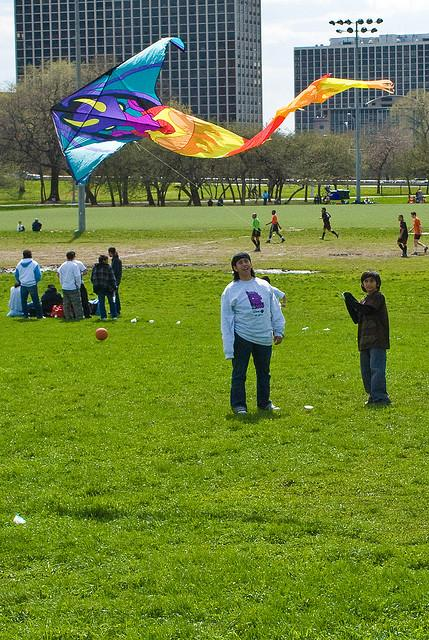The object in the air is in the shape of what animal? Please explain your reasoning. stingray. The kite is a stingray. 